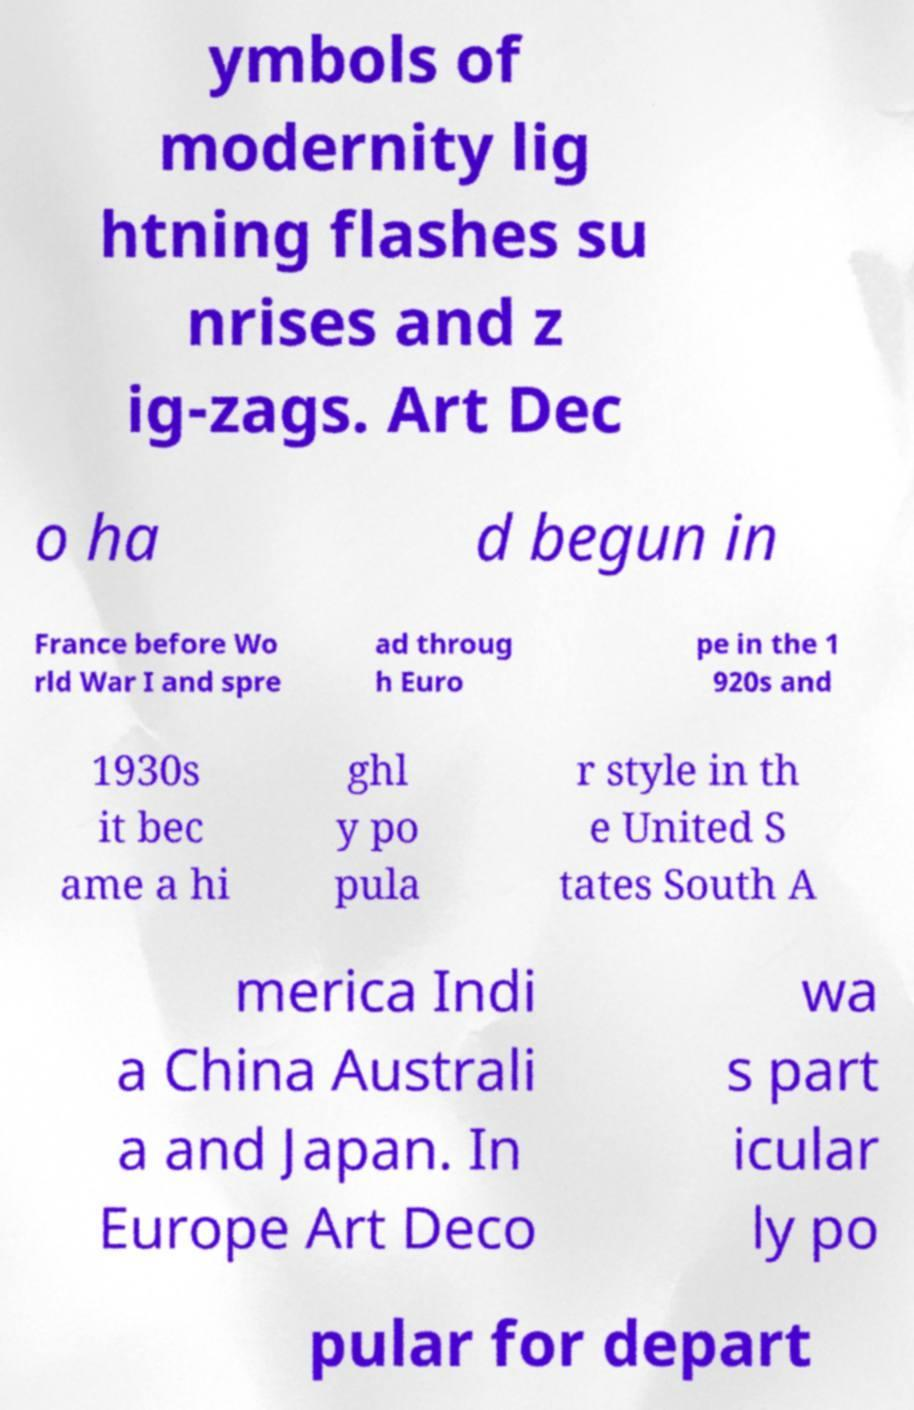Could you extract and type out the text from this image? ymbols of modernity lig htning flashes su nrises and z ig-zags. Art Dec o ha d begun in France before Wo rld War I and spre ad throug h Euro pe in the 1 920s and 1930s it bec ame a hi ghl y po pula r style in th e United S tates South A merica Indi a China Australi a and Japan. In Europe Art Deco wa s part icular ly po pular for depart 